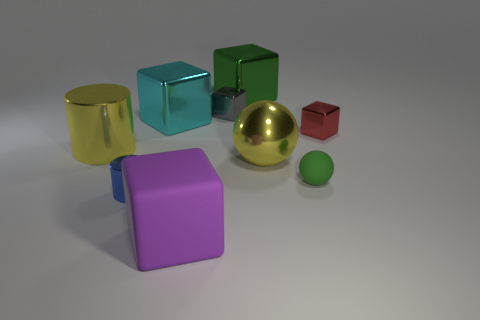Compare the textures of the objects; which ones are more reflective? The gold sphere, silver cylinder, and teal cube are the most reflective objects, exhibiting shiny surfaces that clearly reflect the environment around them. How does the light appear to affect the objects? The light creates highlights and shadows that accentuate the objects' three-dimensionality. Reflective surfaces like those of the gold sphere cast bright highlights and defined reflections, while the more matte surfaces like the purple cube absorb more light, showing diffuse reflections. 